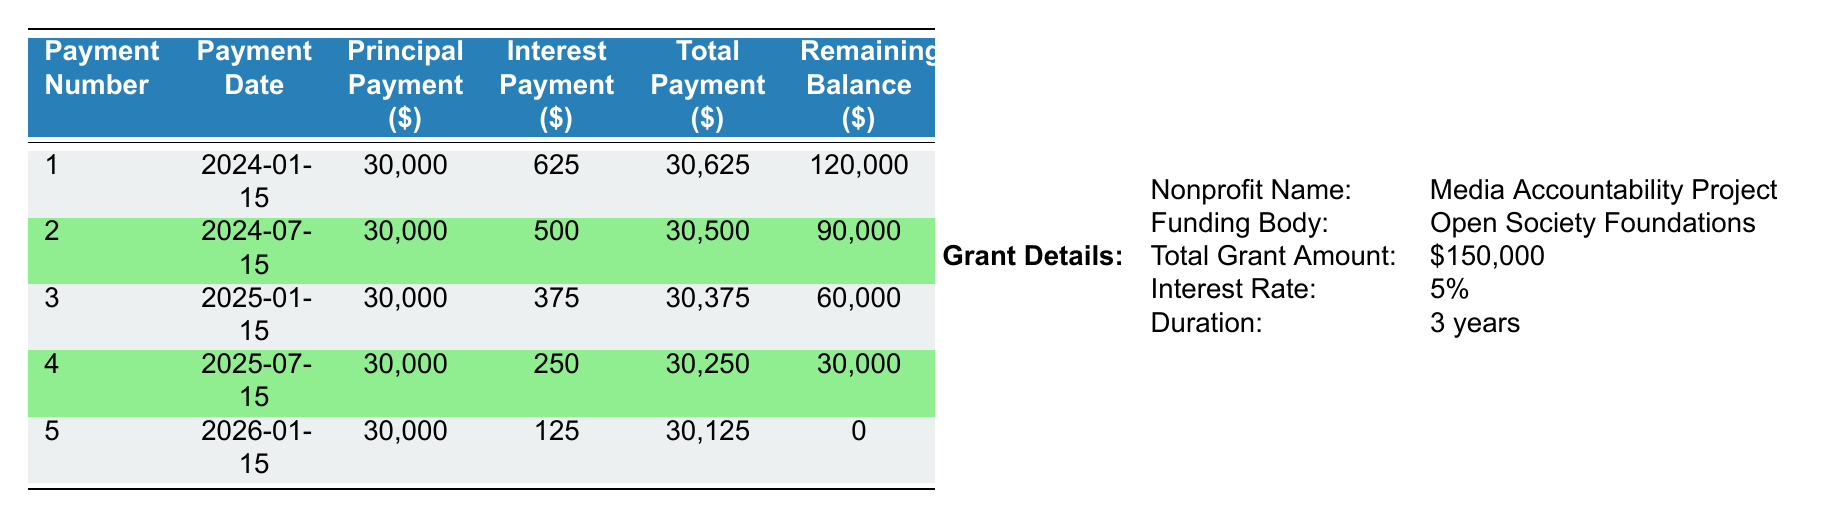What is the total grant amount received by the nonprofit? The table specifies the total grant amount under "Grant Details," which shows that it is $150,000.
Answer: 150,000 What is the interest rate for the grant? The "Grant Details" section of the table indicates that the interest rate is 5%.
Answer: 5% What is the total payment made in the first installment? Referring to the first row under the payment schedule, the "Total Payment" for the first installment is $30,625.
Answer: 30,625 How much was the principal payment in the third installment? In the payment schedule, the "Principal Payment" for the third installment is specified as $30,000.
Answer: 30,000 What is the average total payment over the five installments? To calculate the average total payment: (30625 + 30500 + 30375 + 30250 + 30125) = 151875. There are 5 installments, so the average is 151875 / 5 = 30375.
Answer: 30,375 Did the interest payments decrease with each installment? By examining the "Interest Payment" column in the payment schedule, the amounts are 625, 500, 375, 250, and 125. Each subsequent payment shows a decrease, confirming that interest payments did decrease with each installment.
Answer: Yes What is the remaining balance after the fourth installment? The table shows that after the fourth payment, the "Remaining Balance" is $30,000.
Answer: 30,000 What is the total principal paid off after three installments? To find the total principal paid off after three installments, sum the principal payments for the first three installments: 30000 + 30000 + 30000 = 90000.
Answer: 90,000 How much was the interest payment for the second installment? The second installment lists an "Interest Payment" of $500 in the payment schedule.
Answer: 500 In which installment was the total payment the least? The total payments for each installment are compared: 30625, 30500, 30375, 30250, and 30125. The smallest amount is 30125, occurring in the fifth installment.
Answer: Fifth installment 